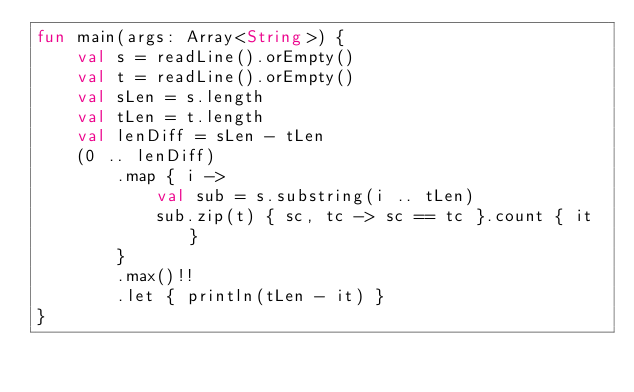<code> <loc_0><loc_0><loc_500><loc_500><_Kotlin_>fun main(args: Array<String>) {
    val s = readLine().orEmpty()
    val t = readLine().orEmpty()
    val sLen = s.length
    val tLen = t.length
    val lenDiff = sLen - tLen
    (0 .. lenDiff)
        .map { i ->
            val sub = s.substring(i .. tLen)
            sub.zip(t) { sc, tc -> sc == tc }.count { it }
        }
        .max()!!
        .let { println(tLen - it) }
}
</code> 